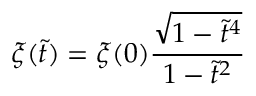<formula> <loc_0><loc_0><loc_500><loc_500>\xi ( \tilde { t } ) = \xi ( 0 ) \frac { \sqrt { 1 - \tilde { t } ^ { 4 } } } { 1 - \tilde { t } ^ { 2 } }</formula> 